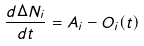<formula> <loc_0><loc_0><loc_500><loc_500>\frac { d \Delta N _ { i } } { d t } = A _ { i } - O _ { i } ( t )</formula> 